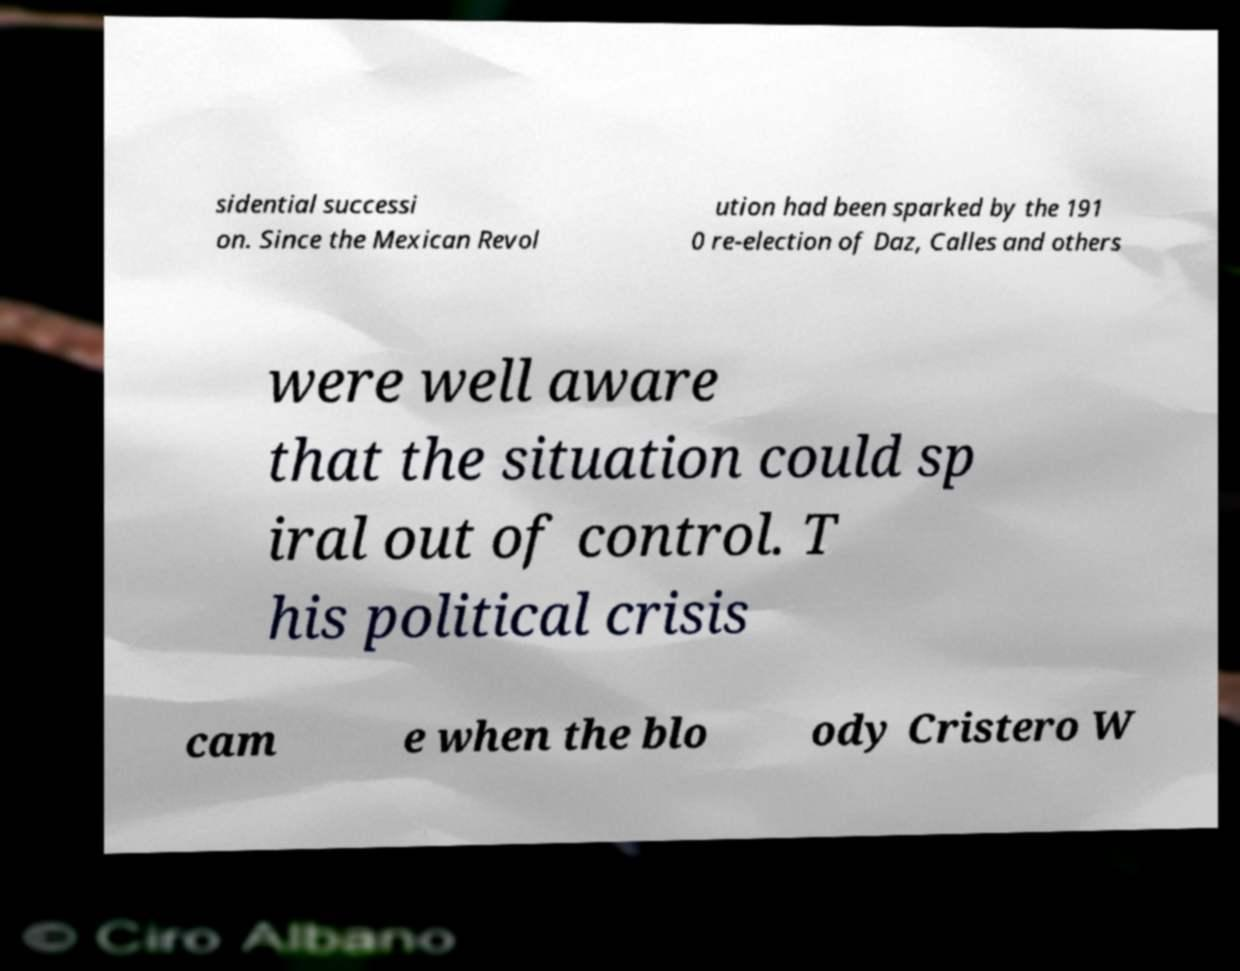Could you extract and type out the text from this image? sidential successi on. Since the Mexican Revol ution had been sparked by the 191 0 re-election of Daz, Calles and others were well aware that the situation could sp iral out of control. T his political crisis cam e when the blo ody Cristero W 